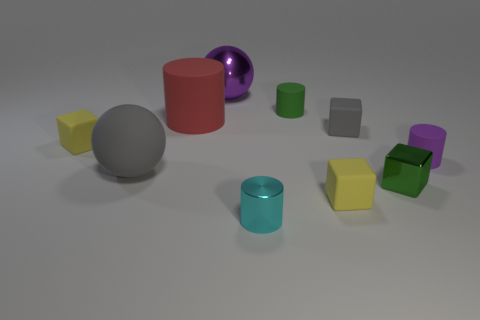Does the cylinder behind the red rubber thing have the same size as the purple rubber thing?
Provide a succinct answer. Yes. What is the size of the rubber thing that is the same color as the large rubber ball?
Give a very brief answer. Small. Are there any red rubber balls of the same size as the shiny cylinder?
Ensure brevity in your answer.  No. Does the small object on the left side of the cyan thing have the same color as the big ball in front of the large purple metal ball?
Make the answer very short. No. Are there any big metallic cylinders of the same color as the large matte sphere?
Keep it short and to the point. No. How many other objects are the same shape as the green rubber object?
Your answer should be very brief. 3. The yellow matte thing in front of the small green shiny thing has what shape?
Offer a very short reply. Cube. Does the green matte object have the same shape as the yellow object on the right side of the large purple metal object?
Give a very brief answer. No. What is the size of the cylinder that is both on the left side of the green rubber thing and to the right of the big matte cylinder?
Your response must be concise. Small. What is the color of the large thing that is both in front of the green matte cylinder and on the right side of the big rubber sphere?
Ensure brevity in your answer.  Red. 